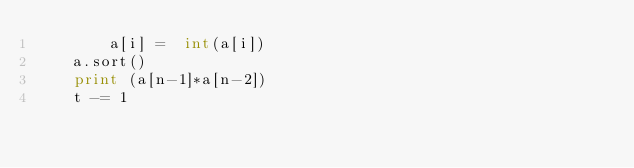Convert code to text. <code><loc_0><loc_0><loc_500><loc_500><_Python_>        a[i] =  int(a[i])
    a.sort()
    print (a[n-1]*a[n-2])
    t -= 1</code> 